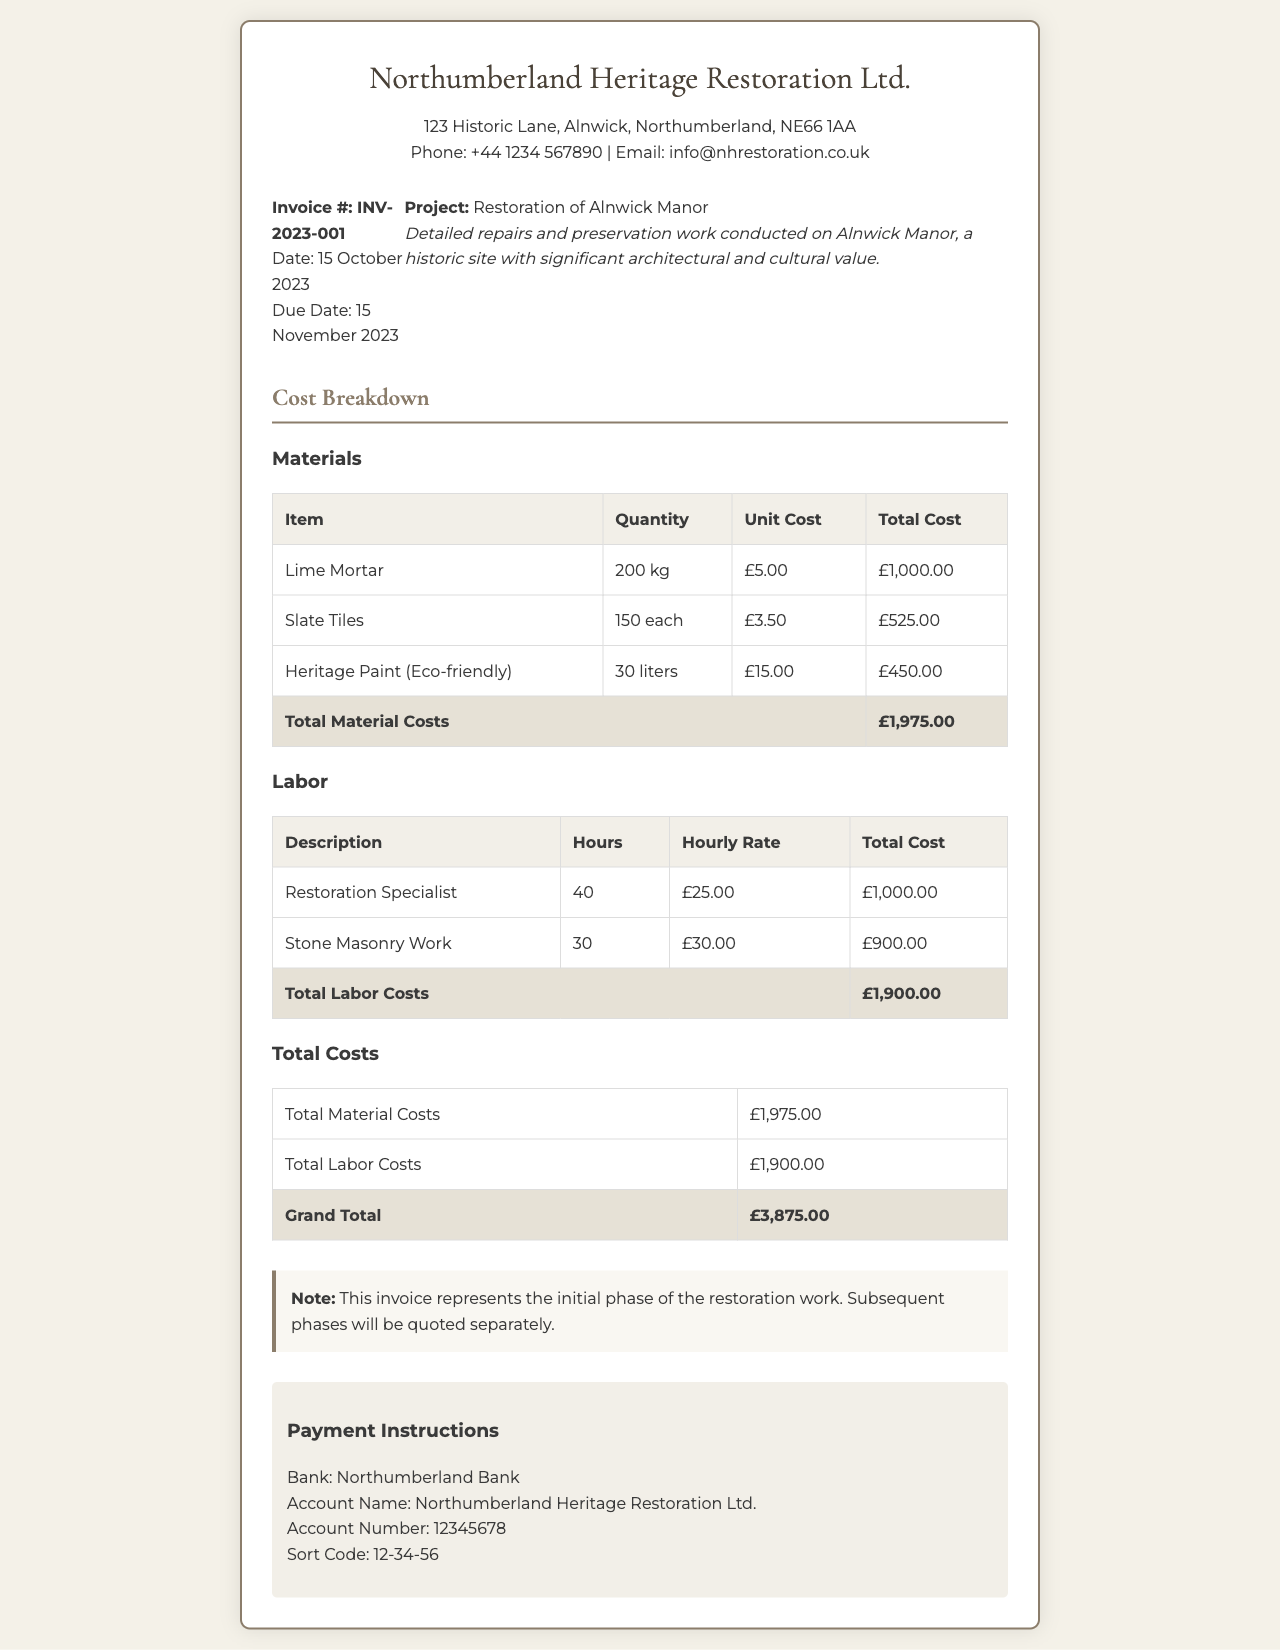What is the invoice number? The invoice number is found in the invoice details section specifically labeled as "Invoice #."
Answer: INV-2023-001 When is the due date for payment? The due date for payment is mentioned in the invoice details as "Due Date."
Answer: 15 November 2023 What is the total cost for materials? The total cost for materials is listed in the "Total Material Costs" row in the material cost breakdown table.
Answer: £1,975.00 How many hours were billed for the Restoration Specialist? The number of hours for the Restoration Specialist can be found in the labor cost breakdown table under the corresponding row.
Answer: 40 What is the grand total of the invoice? The grand total is calculated and provided at the end of the total costs table under "Grand Total."
Answer: £3,875.00 What type of paint was used in the project? The type of paint used is specified in the materials table as an eco-friendly option.
Answer: Heritage Paint (Eco-friendly) Which company issued this invoice? The company issuing the invoice is displayed at the top of the document under the company name.
Answer: Northumberland Heritage Restoration Ltd What is stated in the notes section? The notes section includes a specific statement regarding the phase of work represented in the invoice.
Answer: This invoice represents the initial phase of the restoration work. Subsequent phases will be quoted separately What is the hourly rate for Stone Masonry Work? The hourly rate for Stone Masonry Work can be found in the labor cost breakdown table under the relevant row.
Answer: £30.00 